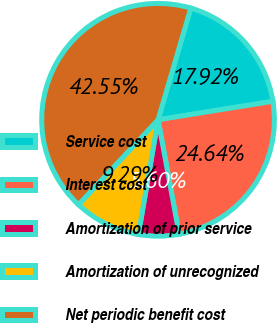Convert chart to OTSL. <chart><loc_0><loc_0><loc_500><loc_500><pie_chart><fcel>Service cost<fcel>Interest cost<fcel>Amortization of prior service<fcel>Amortization of unrecognized<fcel>Net periodic benefit cost<nl><fcel>17.92%<fcel>24.64%<fcel>5.6%<fcel>9.29%<fcel>42.55%<nl></chart> 